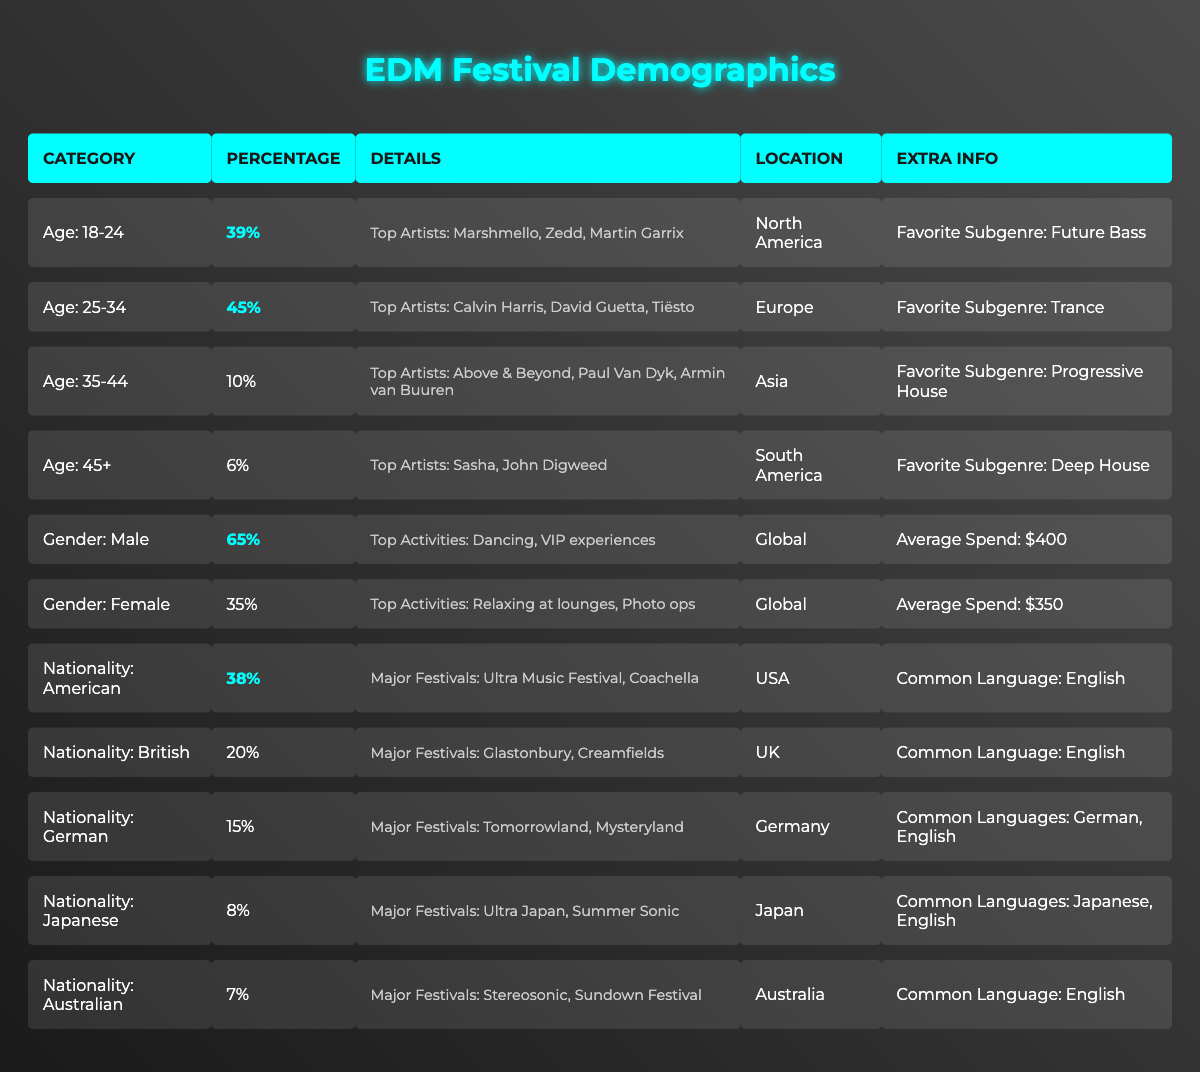What age group has the highest percentage in the audience demographics? The age demographics show the percentages of different age groups. Looking at the table, the age group "25-34" has the highest percentage of 45%, compared to 39% for "18-24", 10% for "35-44", and 6% for "45+".
Answer: 25-34 What percentage of the audience is female? Referring to the gender demographics, "Female" has a percentage of 35%, while "Male" comprises 65%.
Answer: 35% What are the top three artists for the 18-24 age group? The table specifies that for the age group "18-24", the top artists listed are Marshmello, Zedd, and Martin Garrix.
Answer: Marshmello, Zedd, Martin Garrix Which gender has a higher average spend? The average spend for males is $400 and for females, it is $350. Since $400 is greater than $350, males have a higher average spend.
Answer: Male What is the combined percentage of the "35-44" and "45+" age groups? To get the combined percentage, add the percentages of the two age groups: 10% (for 35-44) + 6% (for 45+) = 16%.
Answer: 16% Is the percentage of Australian audience members more than that of Japanese audience members? The table shows that the percentage of Australians is 7%, and the percentage of Japanese is 8%. Since 7% is less than 8%, the statement is false.
Answer: No What is the primary location of the 25-34 age group? According to the table, the primary location for the age group "25-34" is Europe.
Answer: Europe Which nationality has the highest percentage in the audience demographics? The table indicates that "American" has the highest percentage at 38%, compared to others: British (20%), German (15%), Japanese (8%), and Australian (7%).
Answer: American What is the average percentage of audience members aged 35 and above? The relevant age groups are "35-44" at 10% and "45+" at 6%. The average is calculated as (10% + 6%) / 2 = 8%.
Answer: 8% How many major festivals have American audience members attended compared to German audience members? American audience members attended 2 major festivals (Ultra Music Festival, Coachella) while German audience members also attended 2 major festivals (Tomorrowland, Mysteryland). Therefore, they have attended the same number of festivals.
Answer: Same number (2) 